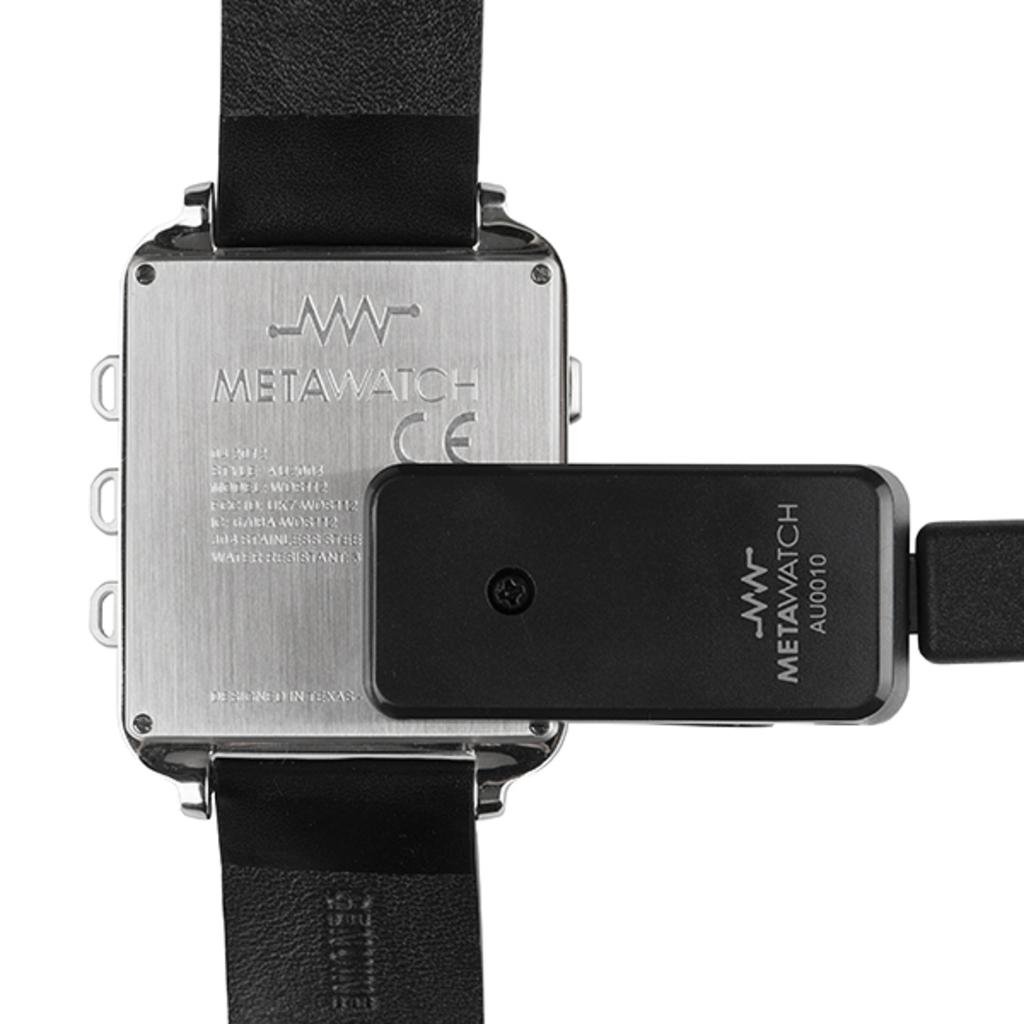<image>
Summarize the visual content of the image. The back of a METAWATCH is made of an engraved silver metal. 